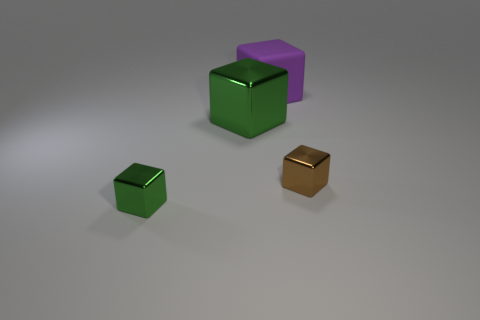Subtract 1 blocks. How many blocks are left? 3 Add 1 tiny brown shiny cubes. How many objects exist? 5 Subtract 0 blue cylinders. How many objects are left? 4 Subtract all metallic objects. Subtract all small brown things. How many objects are left? 0 Add 2 tiny brown metallic blocks. How many tiny brown metallic blocks are left? 3 Add 3 tiny green things. How many tiny green things exist? 4 